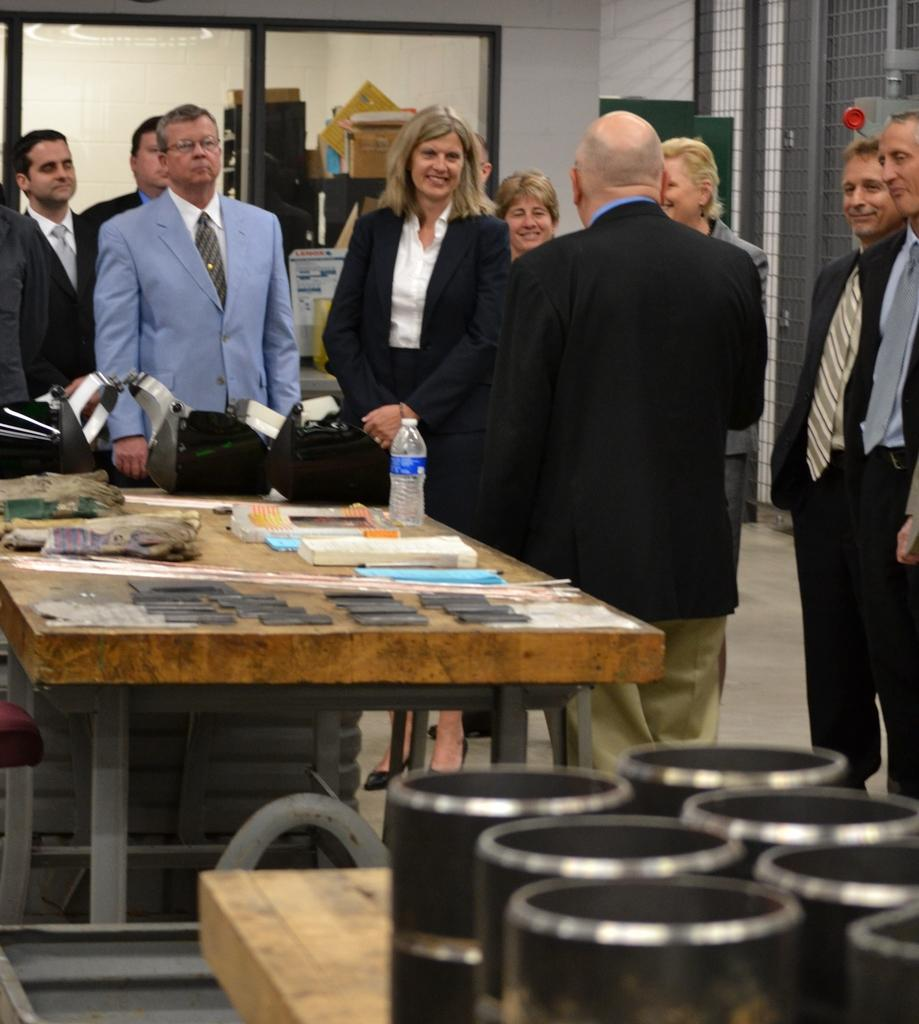What can be seen in the image involving people? There are people standing in the image. Can you describe the expressions on the people's faces? Some people have smiles on their faces. What is present on the table in the image? There are machines and a water bottle on the table. What type of yoke is being used to carry the machines on the table? There is no yoke present in the image, and the machines are not being carried. 